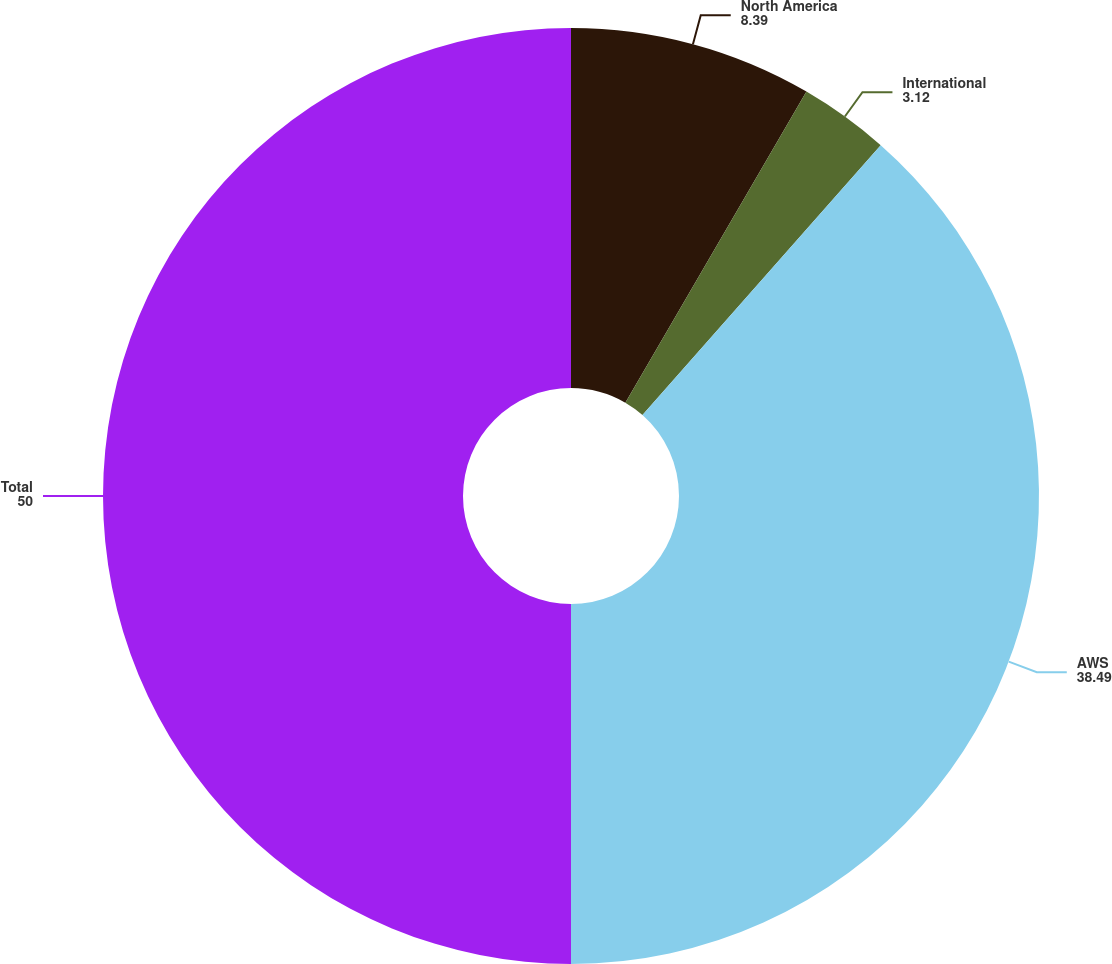<chart> <loc_0><loc_0><loc_500><loc_500><pie_chart><fcel>North America<fcel>International<fcel>AWS<fcel>Total<nl><fcel>8.39%<fcel>3.12%<fcel>38.49%<fcel>50.0%<nl></chart> 